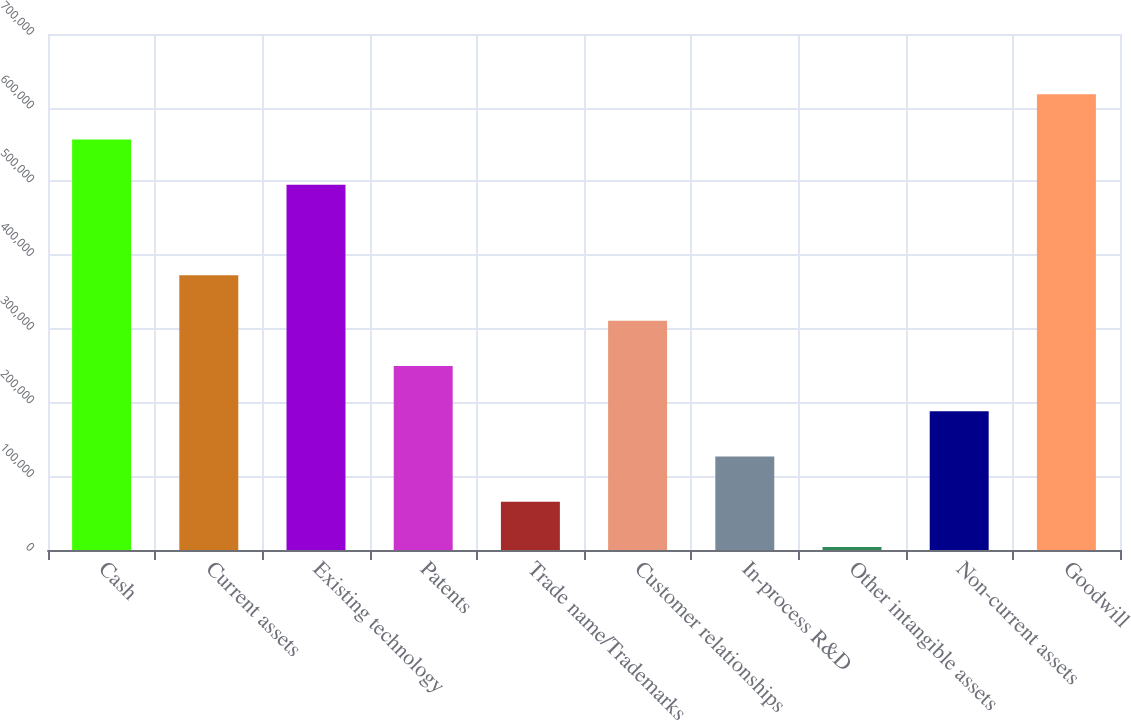Convert chart. <chart><loc_0><loc_0><loc_500><loc_500><bar_chart><fcel>Cash<fcel>Current assets<fcel>Existing technology<fcel>Patents<fcel>Trade name/Trademarks<fcel>Customer relationships<fcel>In-process R&D<fcel>Other intangible assets<fcel>Non-current assets<fcel>Goodwill<nl><fcel>556892<fcel>372595<fcel>495460<fcel>249730<fcel>65432.5<fcel>311162<fcel>126865<fcel>4000<fcel>188298<fcel>618325<nl></chart> 